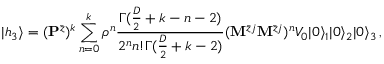Convert formula to latex. <formula><loc_0><loc_0><loc_500><loc_500>| h _ { 3 } \rangle = ( { P } ^ { \bar { z } } ) ^ { k } \sum _ { n = 0 } ^ { k } \rho ^ { n } \frac { \Gamma ( \frac { D } { 2 } + k - n - 2 ) } { 2 ^ { n } n ! \Gamma ( \frac { D } { 2 } + k - 2 ) } ( { M } ^ { \bar { z } j } { M } ^ { \bar { z } j } ) ^ { n } V _ { 0 } | 0 \rangle _ { 1 } | 0 \rangle _ { 2 } | 0 \rangle _ { 3 } \, ,</formula> 